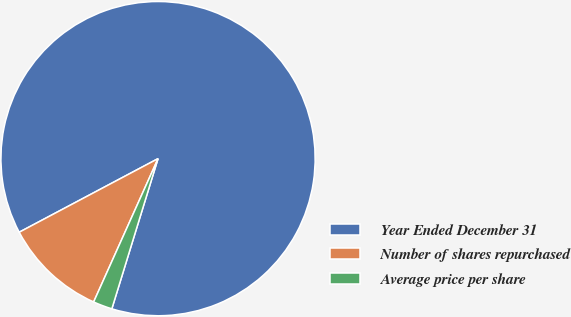Convert chart. <chart><loc_0><loc_0><loc_500><loc_500><pie_chart><fcel>Year Ended December 31<fcel>Number of shares repurchased<fcel>Average price per share<nl><fcel>87.5%<fcel>10.52%<fcel>1.97%<nl></chart> 